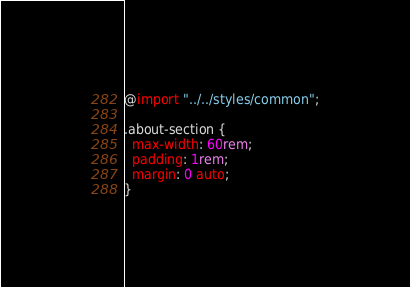<code> <loc_0><loc_0><loc_500><loc_500><_CSS_>@import "../../styles/common";

.about-section {
  max-width: 60rem;
  padding: 1rem;
  margin: 0 auto;
}
</code> 